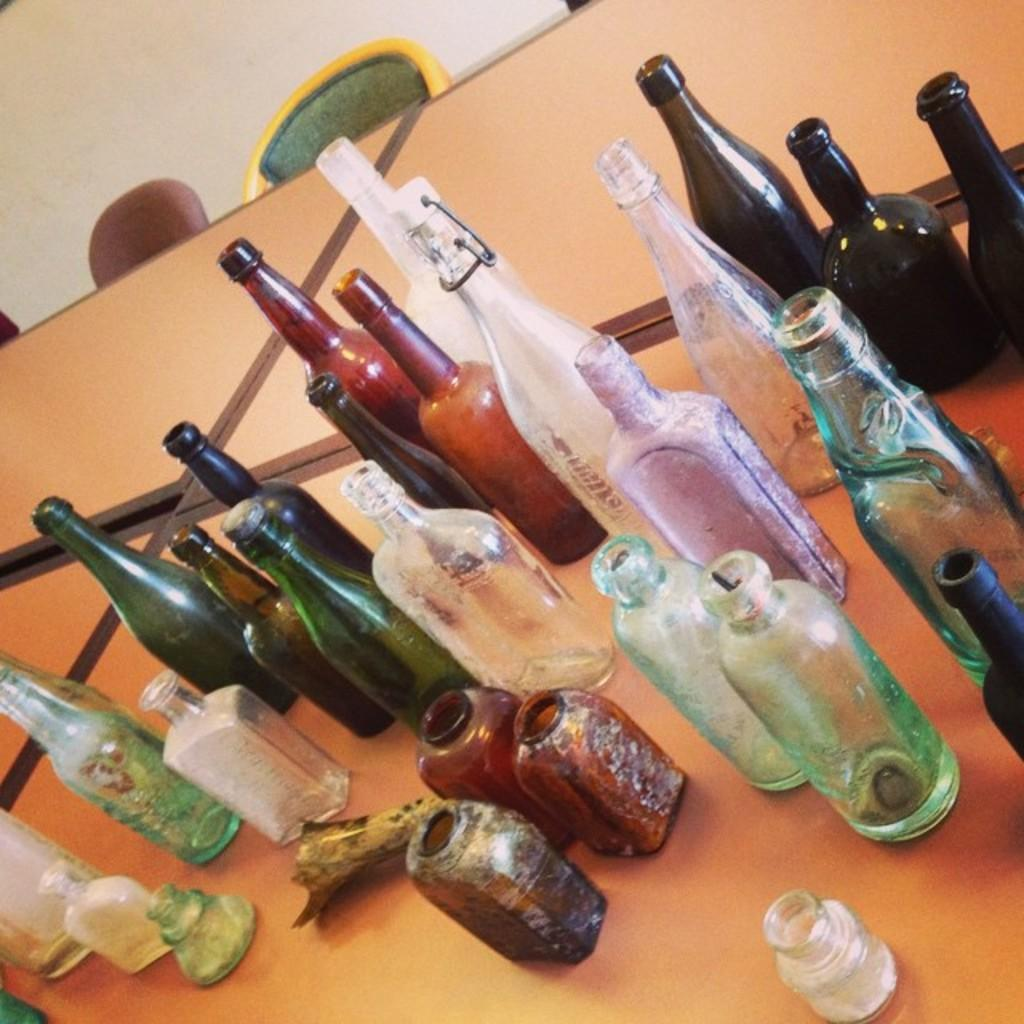What objects are placed on the table in the image? There are many bottles placed on a table in the image. Are there any other objects or furniture near the table? Yes, there are chairs near the table. What type of roof can be seen on the school building in the image? There is no school building or roof present in the image; it only features a table with bottles and chairs nearby. 